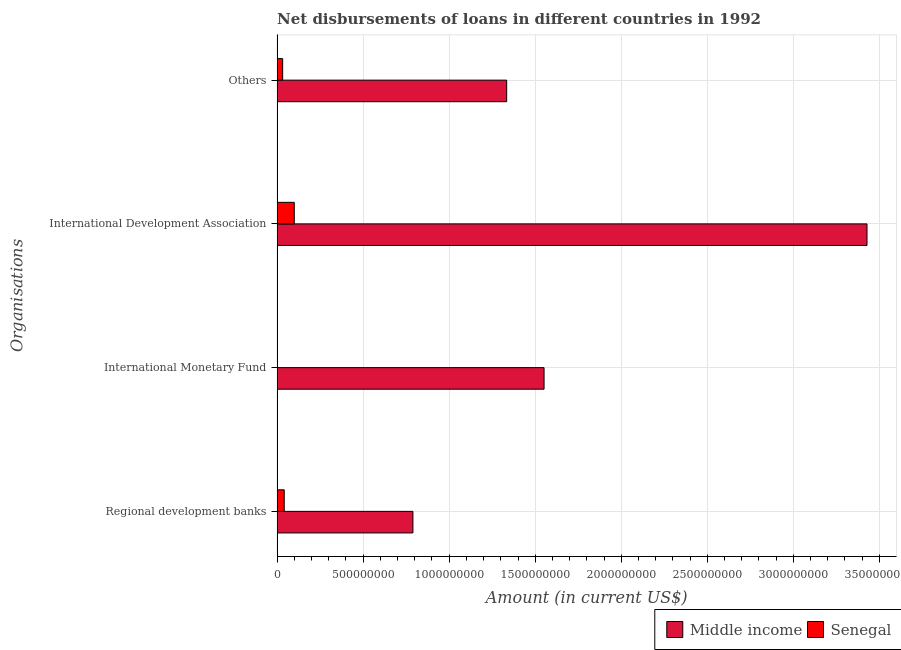How many different coloured bars are there?
Your response must be concise. 2. What is the label of the 1st group of bars from the top?
Offer a terse response. Others. What is the amount of loan disimbursed by international development association in Senegal?
Your answer should be compact. 9.97e+07. Across all countries, what is the maximum amount of loan disimbursed by international development association?
Your answer should be compact. 3.43e+09. Across all countries, what is the minimum amount of loan disimbursed by other organisations?
Give a very brief answer. 3.22e+07. In which country was the amount of loan disimbursed by international development association maximum?
Offer a very short reply. Middle income. What is the total amount of loan disimbursed by regional development banks in the graph?
Your response must be concise. 8.31e+08. What is the difference between the amount of loan disimbursed by other organisations in Middle income and that in Senegal?
Give a very brief answer. 1.30e+09. What is the difference between the amount of loan disimbursed by regional development banks in Middle income and the amount of loan disimbursed by international monetary fund in Senegal?
Your answer should be compact. 7.89e+08. What is the average amount of loan disimbursed by international monetary fund per country?
Provide a short and direct response. 7.76e+08. What is the difference between the amount of loan disimbursed by international development association and amount of loan disimbursed by other organisations in Middle income?
Offer a very short reply. 2.09e+09. What is the ratio of the amount of loan disimbursed by other organisations in Senegal to that in Middle income?
Offer a terse response. 0.02. What is the difference between the highest and the second highest amount of loan disimbursed by international development association?
Make the answer very short. 3.33e+09. What is the difference between the highest and the lowest amount of loan disimbursed by other organisations?
Your answer should be compact. 1.30e+09. Is it the case that in every country, the sum of the amount of loan disimbursed by international development association and amount of loan disimbursed by regional development banks is greater than the sum of amount of loan disimbursed by other organisations and amount of loan disimbursed by international monetary fund?
Ensure brevity in your answer.  No. How many countries are there in the graph?
Offer a terse response. 2. What is the difference between two consecutive major ticks on the X-axis?
Ensure brevity in your answer.  5.00e+08. Are the values on the major ticks of X-axis written in scientific E-notation?
Your response must be concise. No. Does the graph contain grids?
Ensure brevity in your answer.  Yes. Where does the legend appear in the graph?
Your answer should be compact. Bottom right. How are the legend labels stacked?
Offer a terse response. Horizontal. What is the title of the graph?
Your answer should be very brief. Net disbursements of loans in different countries in 1992. Does "Korea (Republic)" appear as one of the legend labels in the graph?
Your answer should be very brief. No. What is the label or title of the X-axis?
Keep it short and to the point. Amount (in current US$). What is the label or title of the Y-axis?
Keep it short and to the point. Organisations. What is the Amount (in current US$) in Middle income in Regional development banks?
Make the answer very short. 7.89e+08. What is the Amount (in current US$) of Senegal in Regional development banks?
Provide a succinct answer. 4.14e+07. What is the Amount (in current US$) of Middle income in International Monetary Fund?
Give a very brief answer. 1.55e+09. What is the Amount (in current US$) in Middle income in International Development Association?
Offer a terse response. 3.43e+09. What is the Amount (in current US$) of Senegal in International Development Association?
Your answer should be compact. 9.97e+07. What is the Amount (in current US$) of Middle income in Others?
Your response must be concise. 1.33e+09. What is the Amount (in current US$) of Senegal in Others?
Provide a short and direct response. 3.22e+07. Across all Organisations, what is the maximum Amount (in current US$) of Middle income?
Your answer should be very brief. 3.43e+09. Across all Organisations, what is the maximum Amount (in current US$) of Senegal?
Provide a succinct answer. 9.97e+07. Across all Organisations, what is the minimum Amount (in current US$) of Middle income?
Provide a succinct answer. 7.89e+08. What is the total Amount (in current US$) in Middle income in the graph?
Your answer should be very brief. 7.10e+09. What is the total Amount (in current US$) of Senegal in the graph?
Provide a succinct answer. 1.73e+08. What is the difference between the Amount (in current US$) in Middle income in Regional development banks and that in International Monetary Fund?
Provide a succinct answer. -7.62e+08. What is the difference between the Amount (in current US$) in Middle income in Regional development banks and that in International Development Association?
Offer a terse response. -2.64e+09. What is the difference between the Amount (in current US$) in Senegal in Regional development banks and that in International Development Association?
Make the answer very short. -5.83e+07. What is the difference between the Amount (in current US$) in Middle income in Regional development banks and that in Others?
Provide a short and direct response. -5.45e+08. What is the difference between the Amount (in current US$) in Senegal in Regional development banks and that in Others?
Make the answer very short. 9.17e+06. What is the difference between the Amount (in current US$) of Middle income in International Monetary Fund and that in International Development Association?
Offer a terse response. -1.88e+09. What is the difference between the Amount (in current US$) of Middle income in International Monetary Fund and that in Others?
Make the answer very short. 2.17e+08. What is the difference between the Amount (in current US$) in Middle income in International Development Association and that in Others?
Give a very brief answer. 2.09e+09. What is the difference between the Amount (in current US$) of Senegal in International Development Association and that in Others?
Provide a short and direct response. 6.75e+07. What is the difference between the Amount (in current US$) of Middle income in Regional development banks and the Amount (in current US$) of Senegal in International Development Association?
Keep it short and to the point. 6.89e+08. What is the difference between the Amount (in current US$) in Middle income in Regional development banks and the Amount (in current US$) in Senegal in Others?
Your response must be concise. 7.57e+08. What is the difference between the Amount (in current US$) in Middle income in International Monetary Fund and the Amount (in current US$) in Senegal in International Development Association?
Offer a terse response. 1.45e+09. What is the difference between the Amount (in current US$) in Middle income in International Monetary Fund and the Amount (in current US$) in Senegal in Others?
Give a very brief answer. 1.52e+09. What is the difference between the Amount (in current US$) in Middle income in International Development Association and the Amount (in current US$) in Senegal in Others?
Provide a short and direct response. 3.40e+09. What is the average Amount (in current US$) in Middle income per Organisations?
Provide a short and direct response. 1.78e+09. What is the average Amount (in current US$) of Senegal per Organisations?
Provide a succinct answer. 4.33e+07. What is the difference between the Amount (in current US$) in Middle income and Amount (in current US$) in Senegal in Regional development banks?
Your answer should be compact. 7.48e+08. What is the difference between the Amount (in current US$) in Middle income and Amount (in current US$) in Senegal in International Development Association?
Your response must be concise. 3.33e+09. What is the difference between the Amount (in current US$) in Middle income and Amount (in current US$) in Senegal in Others?
Your answer should be compact. 1.30e+09. What is the ratio of the Amount (in current US$) of Middle income in Regional development banks to that in International Monetary Fund?
Keep it short and to the point. 0.51. What is the ratio of the Amount (in current US$) of Middle income in Regional development banks to that in International Development Association?
Provide a succinct answer. 0.23. What is the ratio of the Amount (in current US$) of Senegal in Regional development banks to that in International Development Association?
Offer a very short reply. 0.41. What is the ratio of the Amount (in current US$) in Middle income in Regional development banks to that in Others?
Give a very brief answer. 0.59. What is the ratio of the Amount (in current US$) of Senegal in Regional development banks to that in Others?
Make the answer very short. 1.28. What is the ratio of the Amount (in current US$) of Middle income in International Monetary Fund to that in International Development Association?
Make the answer very short. 0.45. What is the ratio of the Amount (in current US$) in Middle income in International Monetary Fund to that in Others?
Ensure brevity in your answer.  1.16. What is the ratio of the Amount (in current US$) in Middle income in International Development Association to that in Others?
Offer a terse response. 2.57. What is the ratio of the Amount (in current US$) in Senegal in International Development Association to that in Others?
Your answer should be very brief. 3.1. What is the difference between the highest and the second highest Amount (in current US$) of Middle income?
Offer a terse response. 1.88e+09. What is the difference between the highest and the second highest Amount (in current US$) in Senegal?
Offer a very short reply. 5.83e+07. What is the difference between the highest and the lowest Amount (in current US$) of Middle income?
Your response must be concise. 2.64e+09. What is the difference between the highest and the lowest Amount (in current US$) in Senegal?
Your response must be concise. 9.97e+07. 